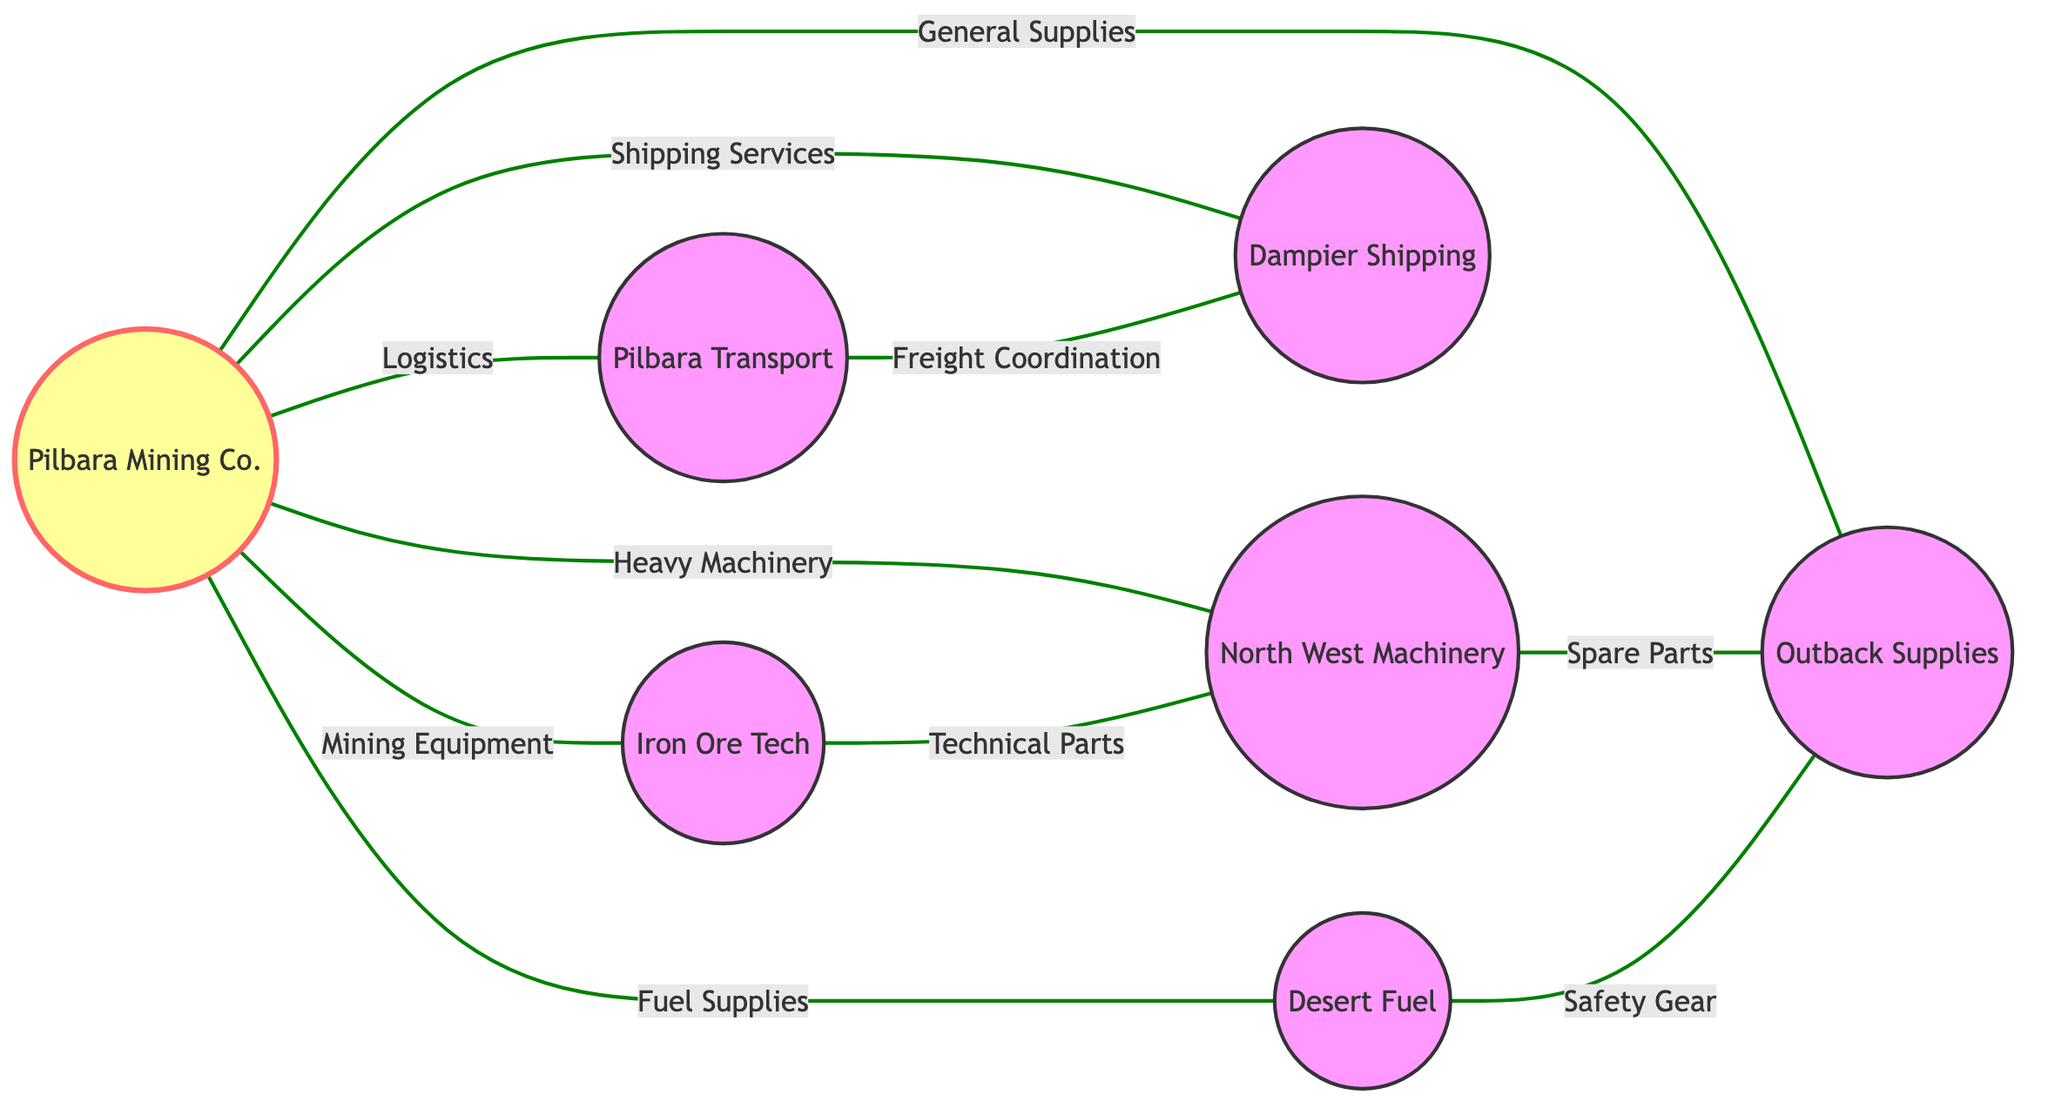What's the total number of nodes in the diagram? The diagram lists 7 nodes: Pilbara Mining Co., Iron Ore Tech, Pilbara Transport, North West Machinery, Dampier Shipping, Outback Supplies, and Desert Fuel. Counting these gives a total of 7 nodes.
Answer: 7 Which supplier provides Fuel Supplies? The node Desert Fuel is directly connected to Pilbara Mining Co. with the edge labeled Fuel Supplies. This shows that Desert Fuel is the supplier for Fuel Supplies.
Answer: Desert Fuel How many edges are connected to Pilbara Mining Co.? The edges connected to Pilbara Mining Co. include Mining Equipment, Logistics, Heavy Machinery, Shipping Services, General Supplies, and Fuel Supplies, totaling 6 edges.
Answer: 6 What is the relationship between Iron Ore Tech and North West Machinery? There is an edge labeled Technical Parts connecting Iron Ore Tech to North West Machinery, which indicates the relationship between these two nodes.
Answer: Technical Parts Which supplier has a direct connection for Safety Gear? The edge connecting Desert Fuel to Outback Supplies is labeled Safety Gear, meaning Desert Fuel supplies Safety Gear through Outback Supplies.
Answer: Desert Fuel Which supplier offers Spare Parts? North West Machinery is connected to Outback Supplies with an edge labeled Spare Parts, indicating that Outback Supplies gets Spare Parts from North West Machinery.
Answer: North West Machinery Which node connects Pilbara Transport and Dampier Shipping? The edge labeled Freight Coordination represents the connection between Pilbara Transport and Dampier Shipping, showing their relationship in logistics.
Answer: Freight Coordination Is there a direct connection between Outback Supplies and Iron Ore Tech? There is no direct edge connecting Outback Supplies to Iron Ore Tech in the provided diagram, indicating no direct relationship between them.
Answer: No How many different product categories does Pilbara Mining Co. manage? Pilbara Mining Co. manages six different product categories as indicated by its six edges connecting to different suppliers.
Answer: 6 